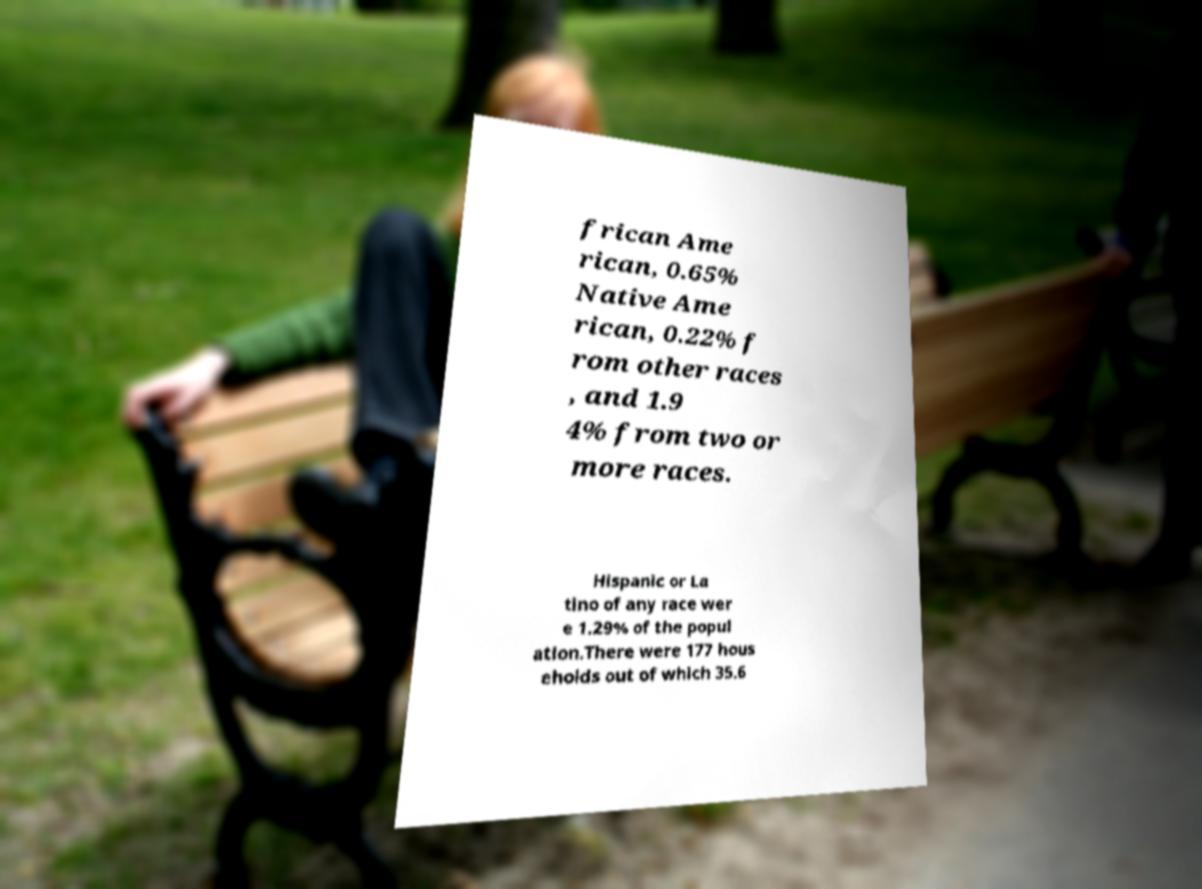Please read and relay the text visible in this image. What does it say? frican Ame rican, 0.65% Native Ame rican, 0.22% f rom other races , and 1.9 4% from two or more races. Hispanic or La tino of any race wer e 1.29% of the popul ation.There were 177 hous eholds out of which 35.6 